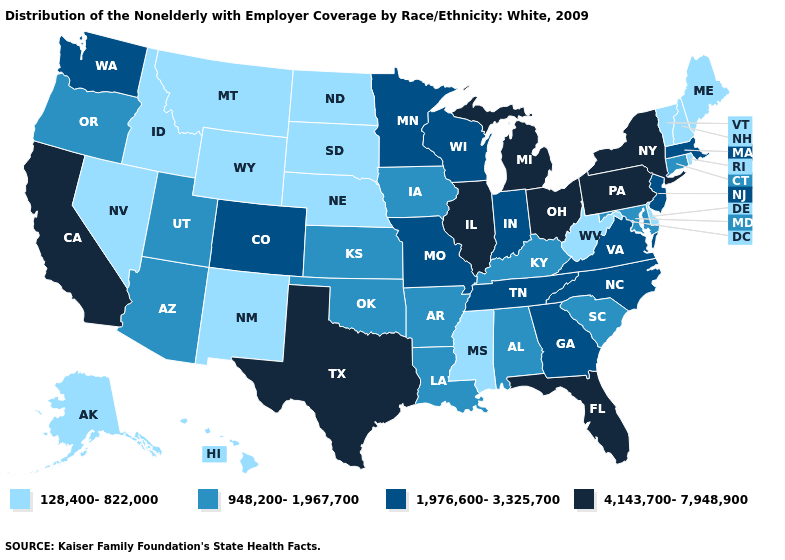Does North Carolina have the lowest value in the USA?
Be succinct. No. Name the states that have a value in the range 4,143,700-7,948,900?
Answer briefly. California, Florida, Illinois, Michigan, New York, Ohio, Pennsylvania, Texas. What is the value of New Jersey?
Be succinct. 1,976,600-3,325,700. Is the legend a continuous bar?
Write a very short answer. No. What is the value of Hawaii?
Answer briefly. 128,400-822,000. Among the states that border Colorado , which have the lowest value?
Short answer required. Nebraska, New Mexico, Wyoming. Among the states that border Utah , does Colorado have the highest value?
Quick response, please. Yes. Name the states that have a value in the range 1,976,600-3,325,700?
Short answer required. Colorado, Georgia, Indiana, Massachusetts, Minnesota, Missouri, New Jersey, North Carolina, Tennessee, Virginia, Washington, Wisconsin. What is the value of Illinois?
Write a very short answer. 4,143,700-7,948,900. Does Pennsylvania have the highest value in the Northeast?
Give a very brief answer. Yes. What is the lowest value in the South?
Be succinct. 128,400-822,000. Does South Carolina have the same value as Florida?
Give a very brief answer. No. Does California have the highest value in the West?
Be succinct. Yes. Name the states that have a value in the range 1,976,600-3,325,700?
Be succinct. Colorado, Georgia, Indiana, Massachusetts, Minnesota, Missouri, New Jersey, North Carolina, Tennessee, Virginia, Washington, Wisconsin. 